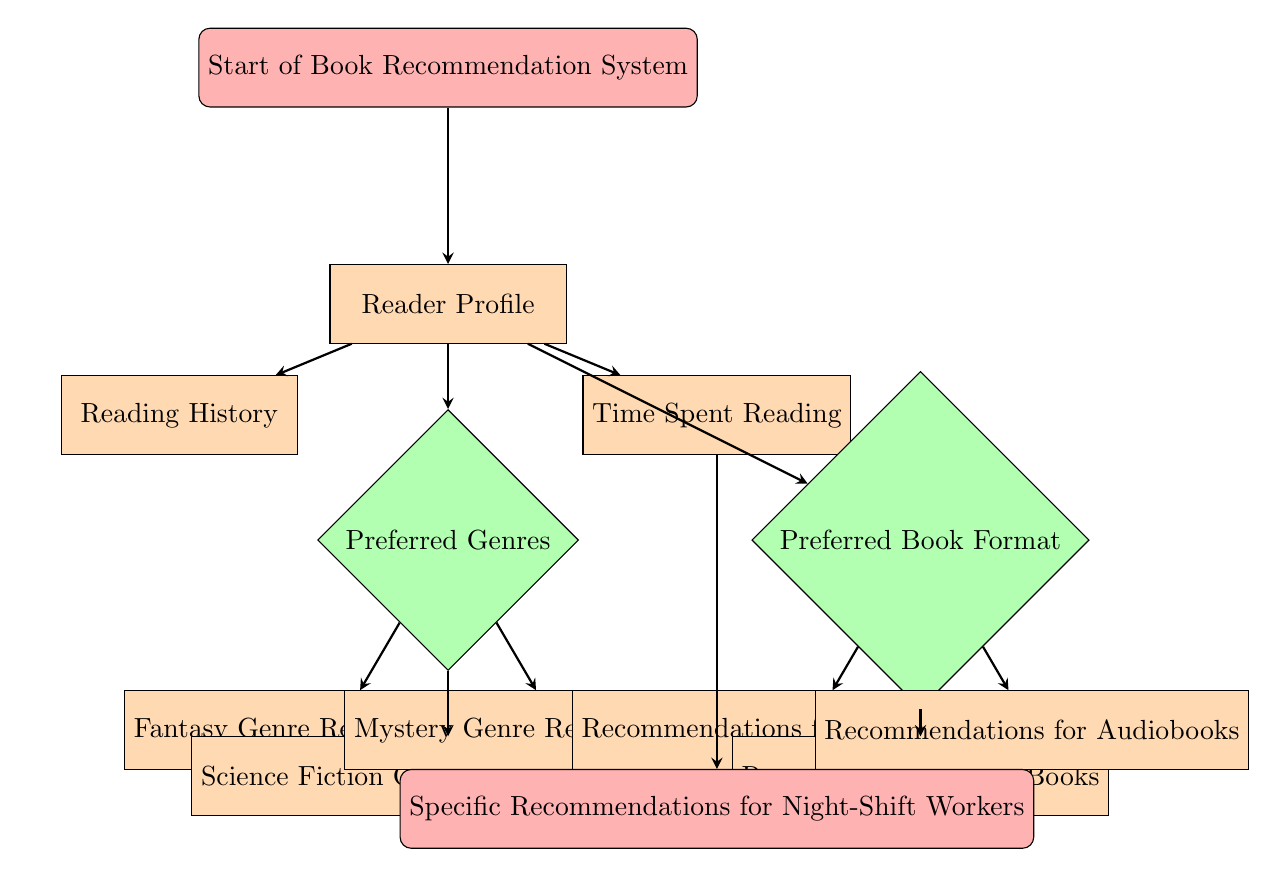What is the first step in the diagram? The diagram starts with the "Start of Book Recommendation System" node, indicating the initial step of the process.
Answer: Start of Book Recommendation System How many different preferred genres are listed in the diagram? The diagram shows three preferred genres: Fantasy, Science Fiction, and Mystery, which are connected as outputs from the "Preferred Genres" decision node.
Answer: Three What does the "Time Spent Reading" process lead to? The "Time Spent Reading" process directly leads to the "Specific Recommendations for Night-Shift Workers" node, showing a specific output based on how much time the reader spends reading.
Answer: Specific Recommendations for Night-Shift Workers Which genres have recommendations listed under them? The genres with recommendations are Fantasy, Science Fiction, and Mystery, indicated as outputs from the "Preferred Genres" decision node.
Answer: Fantasy, Science Fiction, Mystery What types of book formats are recommended based on the "Preferred Book Format" decision node? The recommended book formats are Physical Books, eBooks, and Audiobooks, which come from the "Preferred Book Format" node.
Answer: Physical Books, eBooks, Audiobooks Which node does the "Reading History" process connect to? The "Reading History" process connects to the "Reader Profile" node as part of understanding the reader's background and previous choices.
Answer: Reader Profile What color represents the decision nodes in the diagram? The decision nodes are represented in green, which visually distinguishes them from process and start/stop nodes.
Answer: Green Which node is the last step for genre recommendations? The last step for genre recommendations is the "Mystery Genre Recommendations" process, as it is the last to be shown connected to the "Preferred Genres" decision node.
Answer: Mystery Genre Recommendations What type of diagram is this? This diagram is a Decision Tree, which is designed to represent a recommendation system based on various factors.
Answer: Decision Tree 